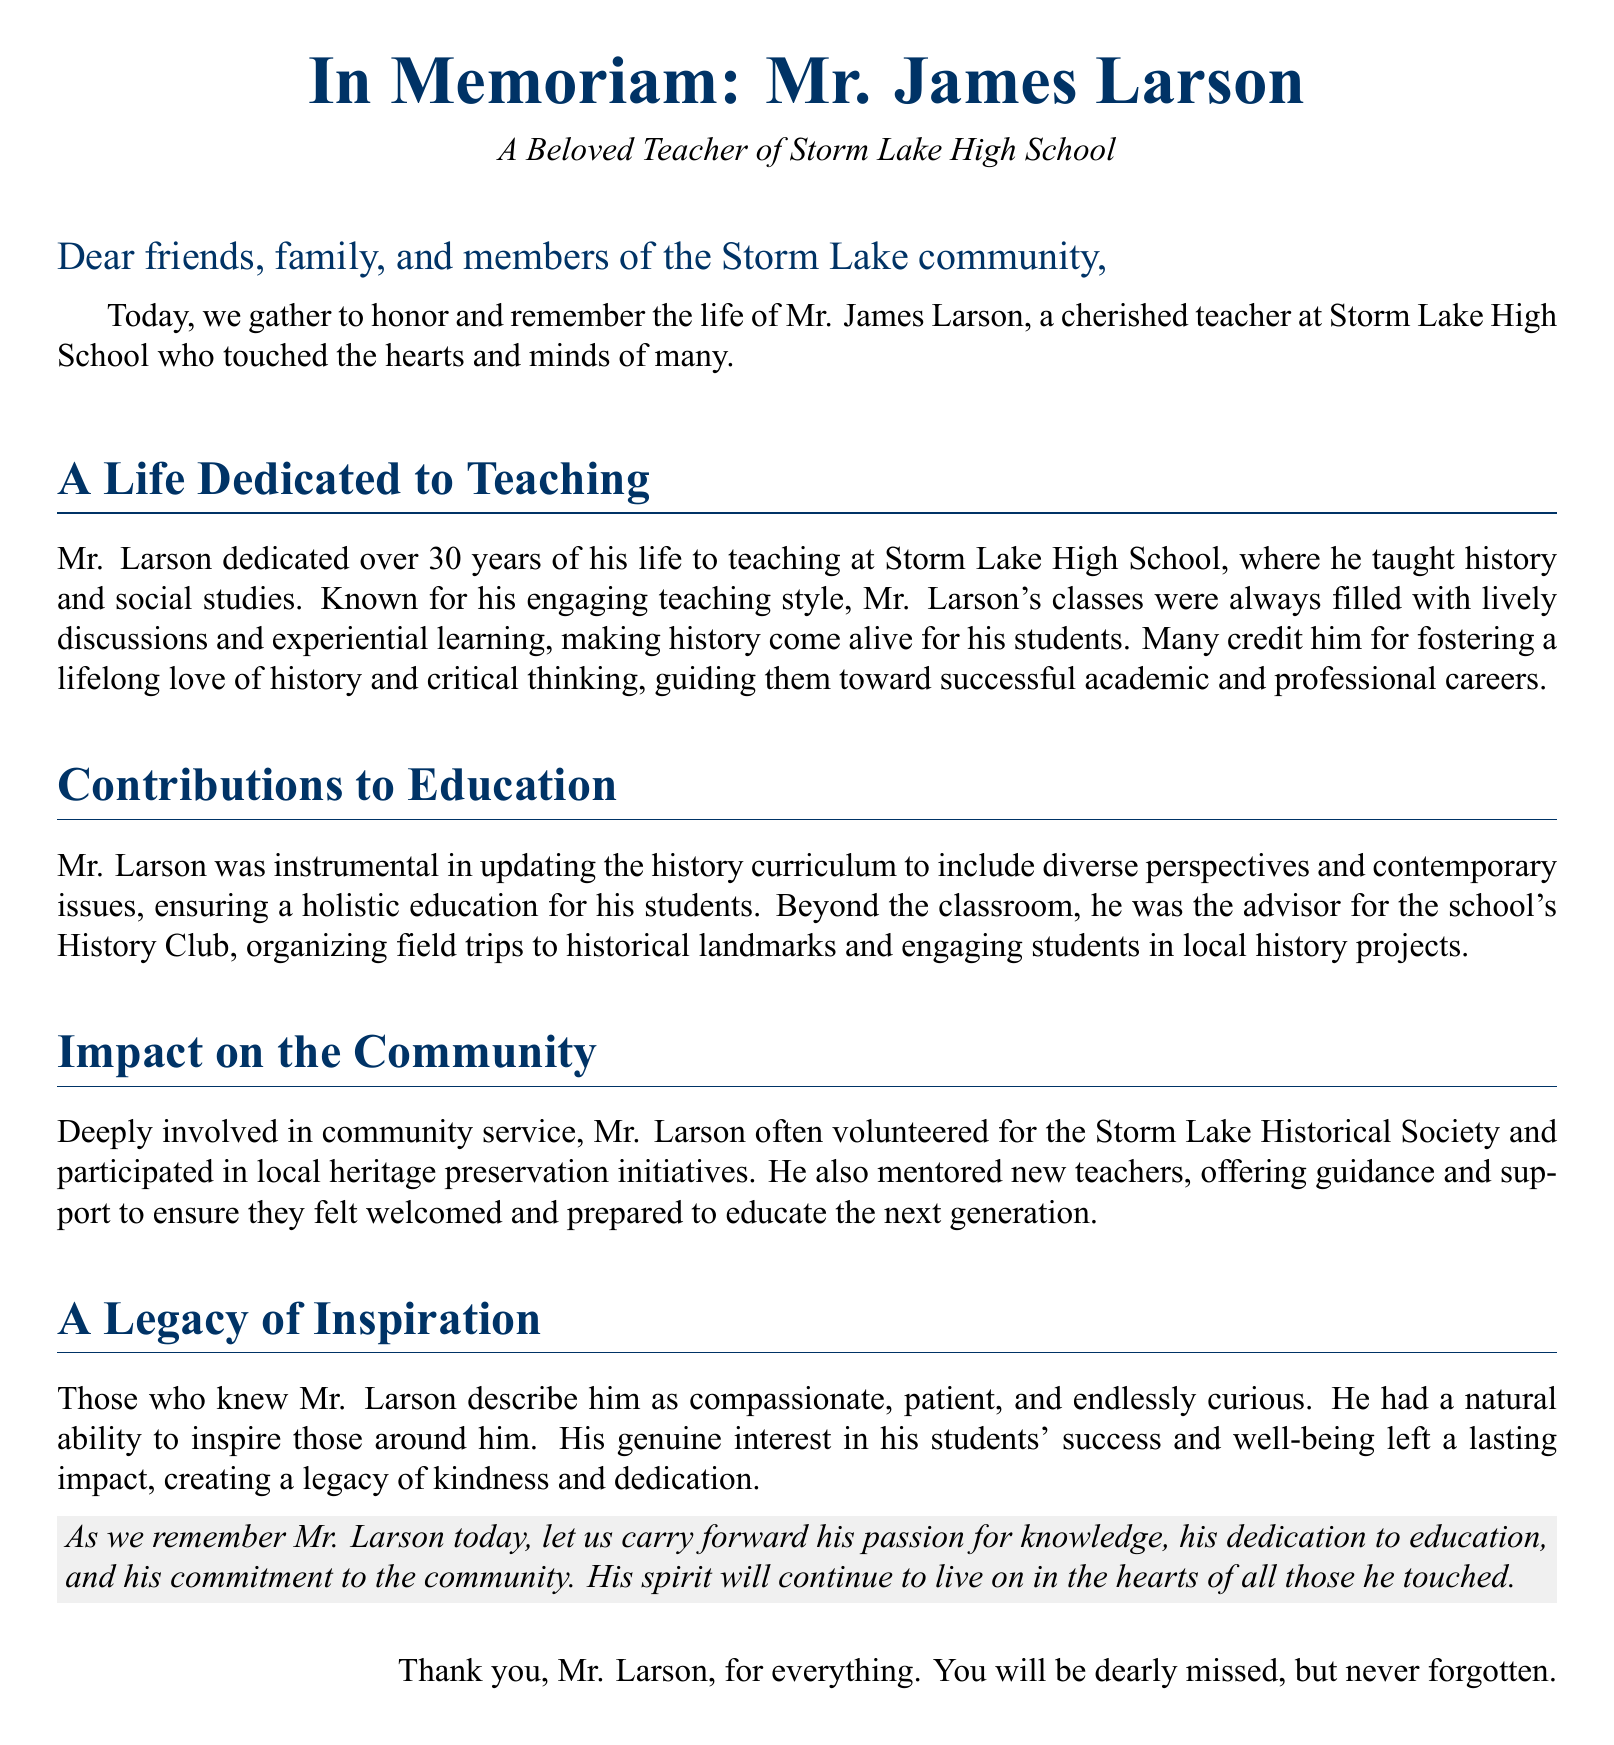What was Mr. Larson's profession? The document states that Mr. Larson was a cherished teacher at Storm Lake High School.
Answer: Teacher How many years did Mr. Larson dedicate to teaching? The document mentions that Mr. Larson dedicated over 30 years of his life to teaching.
Answer: Over 30 years What subject did Mr. Larson teach? According to the document, Mr. Larson taught history and social studies.
Answer: History and social studies What club did Mr. Larson advise at the school? The document indicates that Mr. Larson was the advisor for the school's History Club.
Answer: History Club What type of initiatives did Mr. Larson participate in within the community? The document notes that he participated in local heritage preservation initiatives.
Answer: Local heritage preservation initiatives How did Mr. Larson's students describe him? The document mentions that those who knew Mr. Larson describe him as compassionate, patient, and endlessly curious.
Answer: Compassionate, patient, endlessly curious What was one of Mr. Larson’s contributions to education? The document states that he was instrumental in updating the history curriculum to include diverse perspectives.
Answer: Updating the history curriculum What did Mr. Larson foster in his students? The document notes that many credit him for fostering a lifelong love of history and critical thinking.
Answer: Lifelong love of history and critical thinking What is Mr. Larson's legacy according to the document? The document says he created a legacy of kindness and dedication.
Answer: Kindness and dedication 